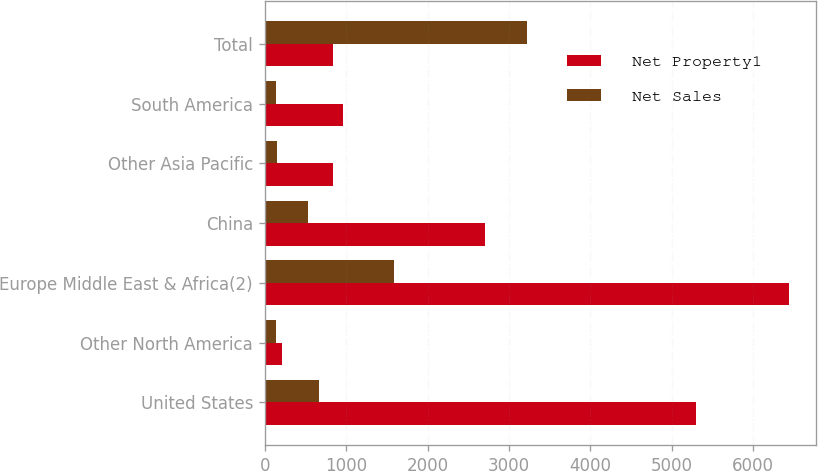Convert chart. <chart><loc_0><loc_0><loc_500><loc_500><stacked_bar_chart><ecel><fcel>United States<fcel>Other North America<fcel>Europe Middle East & Africa(2)<fcel>China<fcel>Other Asia Pacific<fcel>South America<fcel>Total<nl><fcel>Net Property1<fcel>5300<fcel>213<fcel>6444<fcel>2703<fcel>838<fcel>965<fcel>838<nl><fcel>Net Sales<fcel>668<fcel>145<fcel>1592<fcel>526<fcel>148<fcel>137<fcel>3216<nl></chart> 